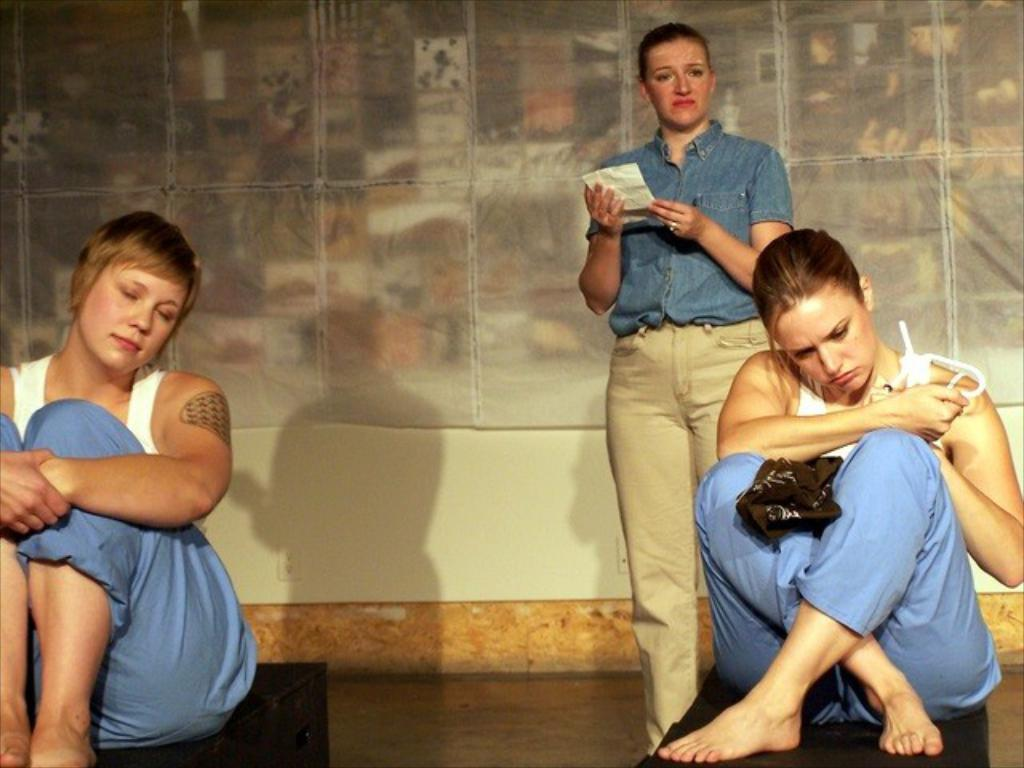How many people are present in the image? There are two persons sitting and one person standing in the image, making a total of three people. What are the people in the image doing? The people are sitting and standing, but their specific actions are not clear from the provided facts. What can be seen in the background of the image? There is a cloth and a wall in the background of the image. What type of animal is wearing a scarf in the image? There is no animal or scarf present in the image. What season is depicted in the image? The provided facts do not give any information about the season or weather in the image. 